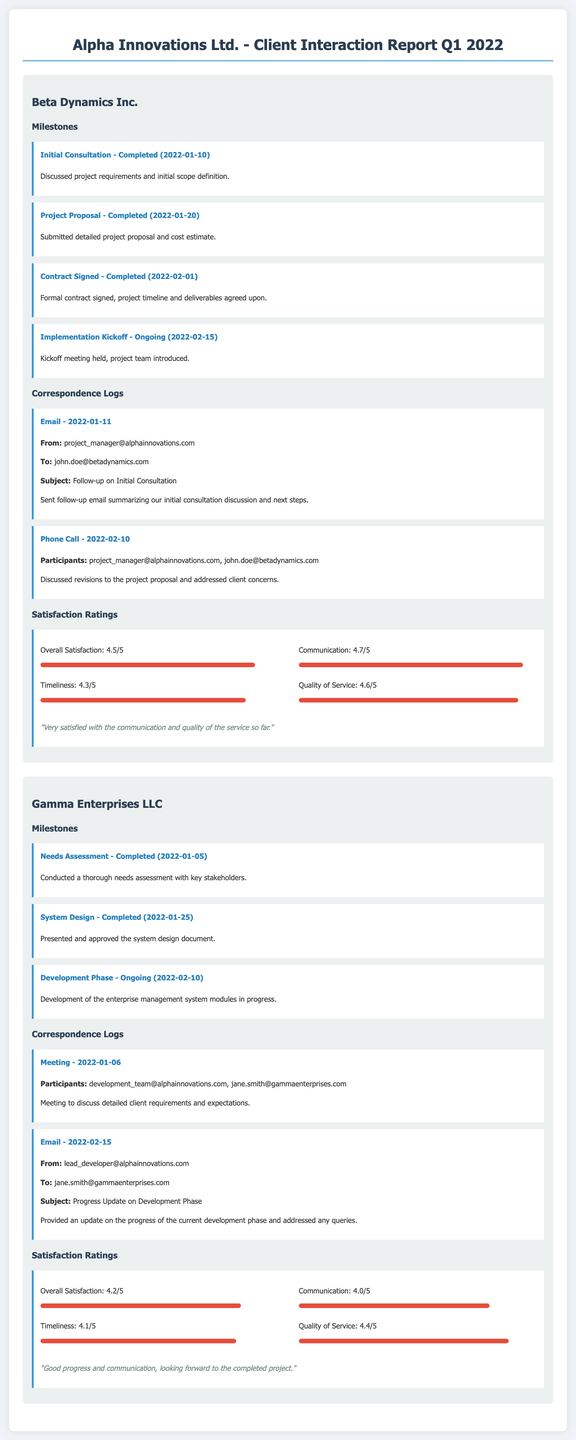What is the overall satisfaction rating for Beta Dynamics Inc.? Overall satisfaction rating is explicitly stated in the document as 4.5 out of 5.
Answer: 4.5/5 What was the date of the contract signing for Beta Dynamics Inc.? The contract signing date is detailed in the milestones section as February 1, 2022.
Answer: 2022-02-01 What type of correspondence took place on January 11, 2022, for Beta Dynamics Inc.? The correspondence log indicates an email was sent on that date.
Answer: Email What milestone is currently ongoing for Gamma Enterprises LLC? The ongoing milestone for Gamma Enterprises LLC is the Development Phase listed in the milestones section.
Answer: Development Phase What is the communication satisfaction rating for Gamma Enterprises LLC? The communication satisfaction is provided in the satisfaction ratings as 4.0 out of 5.
Answer: 4.0/5 How many milestones are completed for Beta Dynamics Inc.? The document lists three completed milestones for Beta Dynamics Inc. in the milestones section.
Answer: 3 What was the subject of the email sent to Gamma Enterprises LLC on February 15, 2022? The subject of the email is specified in the correspondence log as "Progress Update on Development Phase."
Answer: Progress Update on Development Phase Who participated in the meeting on January 6, 2022, regarding Gamma Enterprises LLC? The participants of the meeting are detailed as development team and Jane Smith.
Answer: development_team@alphainnovations.com, jane.smith@gammaenterprises.com What feedback did Beta Dynamics Inc. provide regarding service quality? The feedback comments section includes "Very satisfied with the communication and quality of the service so far."
Answer: Very satisfied with the communication and quality of the service so far 